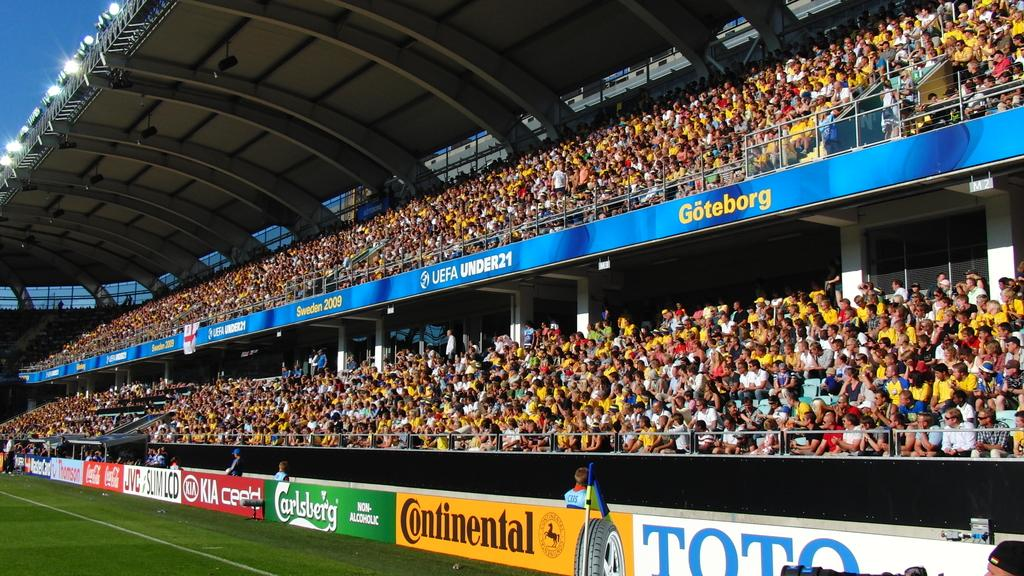<image>
Offer a succinct explanation of the picture presented. An indoor stadium that has several advertisements and one that says Continental 